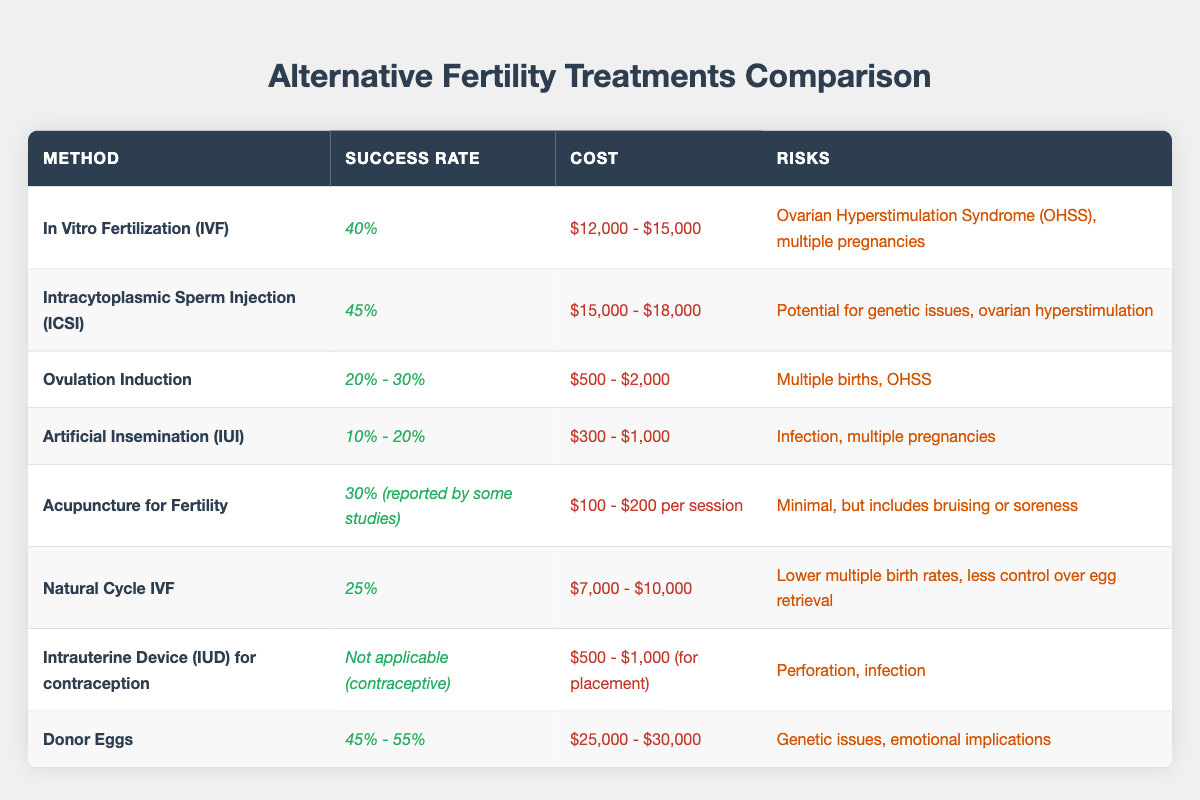What is the success rate of In Vitro Fertilization (IVF)? The table shows that the success rate of In Vitro Fertilization (IVF) is 40%.
Answer: 40% What treatment has the highest success rate? According to the table, Donor Eggs have the highest success rate, ranging from 45% to 55%.
Answer: Donor Eggs What is the cost range for Acupuncture for Fertility? The table lists the cost range for Acupuncture for Fertility as $100 to $200 per session.
Answer: $100 - $200 Is the success rate of Artificial Insemination (IUI) higher than that of Ovulation Induction? The success rate for IUI is between 10% and 20%, while for Ovulation Induction, it's between 20% and 30%. Therefore, the success rate for Ovulation Induction is higher.
Answer: No What is the average success rate of Intracytoplasmic Sperm Injection (ICSI) and Donor Eggs? ICSI has a success rate of 45%, and the average of Donor Eggs is 50% (midpoint of 45%-55%). The average success rate is (45 + 50) / 2 = 47.5%.
Answer: 47.5% What is the risk associated with Natural Cycle IVF? The table indicates that the risks associated with Natural Cycle IVF include lower multiple birth rates and less control over egg retrieval.
Answer: Lower multiple birth rates, less control over egg retrieval How does the cost of Ovulation Induction compare to that of Donor Eggs? Ovulation Induction costs between $500 and $2,000, while Donor Eggs cost between $25,000 and $30,000. The cost of Donor Eggs is significantly higher than that of Ovulation Induction.
Answer: Donor Eggs are much higher What are the risks involved in using IUD for contraception? According to the table, the risks associated with using an IUD for contraception are perforation and infection.
Answer: Perforation, infection If the success rate of Acupuncture for Fertility is reported by some studies as 30%, is this higher or lower than that of IVF? The success rate for Acupuncture for Fertility is 30%, whereas the success rate for IVF is 40%. Thus, Acupuncture's success rate is lower than IVF's.
Answer: Lower What is the combined success rate of the top three methods: ICSI, Donor Eggs, and IVF? The success rates are 45% for ICSI, an average of 50% for Donor Eggs, and 40% for IVF. The combined success rate is (45 + 50 + 40) / 3 = 45%.
Answer: 45% 